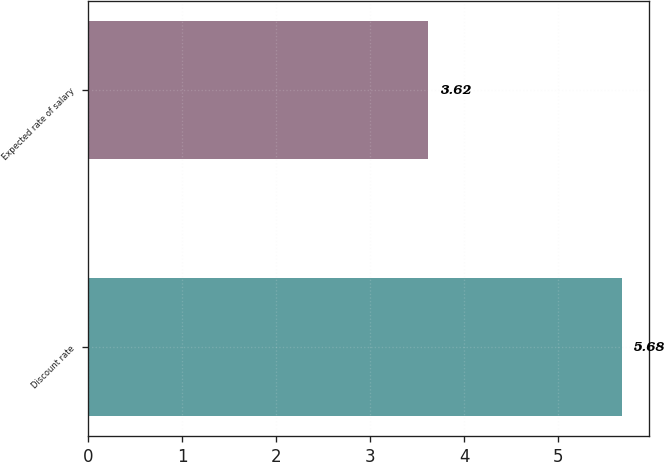<chart> <loc_0><loc_0><loc_500><loc_500><bar_chart><fcel>Discount rate<fcel>Expected rate of salary<nl><fcel>5.68<fcel>3.62<nl></chart> 